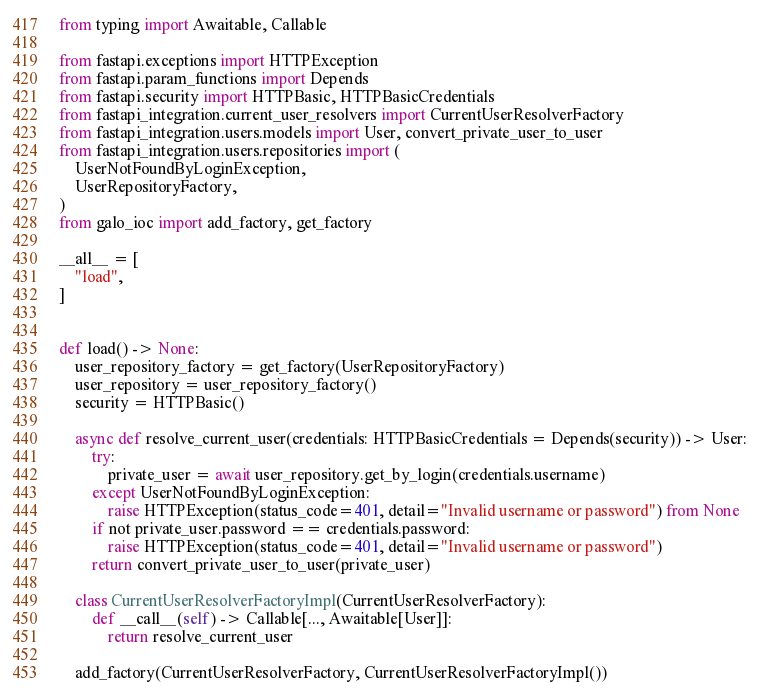<code> <loc_0><loc_0><loc_500><loc_500><_Python_>from typing import Awaitable, Callable

from fastapi.exceptions import HTTPException
from fastapi.param_functions import Depends
from fastapi.security import HTTPBasic, HTTPBasicCredentials
from fastapi_integration.current_user_resolvers import CurrentUserResolverFactory
from fastapi_integration.users.models import User, convert_private_user_to_user
from fastapi_integration.users.repositories import (
    UserNotFoundByLoginException,
    UserRepositoryFactory,
)
from galo_ioc import add_factory, get_factory

__all__ = [
    "load",
]


def load() -> None:
    user_repository_factory = get_factory(UserRepositoryFactory)
    user_repository = user_repository_factory()
    security = HTTPBasic()

    async def resolve_current_user(credentials: HTTPBasicCredentials = Depends(security)) -> User:
        try:
            private_user = await user_repository.get_by_login(credentials.username)
        except UserNotFoundByLoginException:
            raise HTTPException(status_code=401, detail="Invalid username or password") from None
        if not private_user.password == credentials.password:
            raise HTTPException(status_code=401, detail="Invalid username or password")
        return convert_private_user_to_user(private_user)

    class CurrentUserResolverFactoryImpl(CurrentUserResolverFactory):
        def __call__(self) -> Callable[..., Awaitable[User]]:
            return resolve_current_user

    add_factory(CurrentUserResolverFactory, CurrentUserResolverFactoryImpl())
</code> 